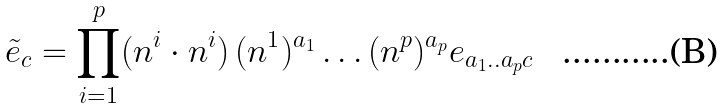Convert formula to latex. <formula><loc_0><loc_0><loc_500><loc_500>\tilde { e } _ { c } = \prod _ { i = 1 } ^ { p } ( n ^ { i } \cdot n ^ { i } ) \, ( n ^ { 1 } ) ^ { a _ { 1 } } \dots ( n ^ { p } ) ^ { a _ { p } } e _ { a _ { 1 } . . a _ { p } c }</formula> 